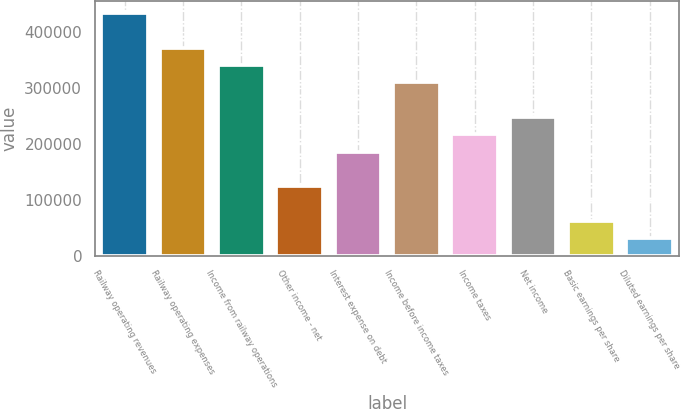<chart> <loc_0><loc_0><loc_500><loc_500><bar_chart><fcel>Railway operating revenues<fcel>Railway operating expenses<fcel>Income from railway operations<fcel>Other income - net<fcel>Interest expense on debt<fcel>Income before income taxes<fcel>Income taxes<fcel>Net income<fcel>Basic earnings per share<fcel>Diluted earnings per share<nl><fcel>433113<fcel>371240<fcel>340304<fcel>123748<fcel>185621<fcel>309367<fcel>216558<fcel>247494<fcel>61875.2<fcel>30938.7<nl></chart> 